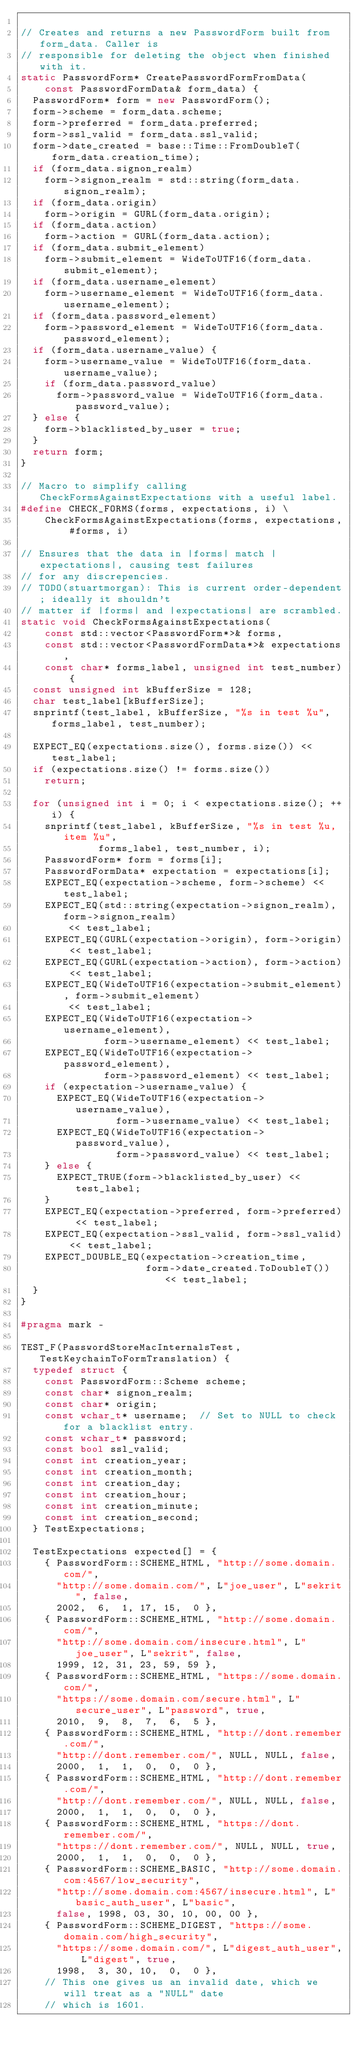Convert code to text. <code><loc_0><loc_0><loc_500><loc_500><_C++_>
// Creates and returns a new PasswordForm built from form_data. Caller is
// responsible for deleting the object when finished with it.
static PasswordForm* CreatePasswordFormFromData(
    const PasswordFormData& form_data) {
  PasswordForm* form = new PasswordForm();
  form->scheme = form_data.scheme;
  form->preferred = form_data.preferred;
  form->ssl_valid = form_data.ssl_valid;
  form->date_created = base::Time::FromDoubleT(form_data.creation_time);
  if (form_data.signon_realm)
    form->signon_realm = std::string(form_data.signon_realm);
  if (form_data.origin)
    form->origin = GURL(form_data.origin);
  if (form_data.action)
    form->action = GURL(form_data.action);
  if (form_data.submit_element)
    form->submit_element = WideToUTF16(form_data.submit_element);
  if (form_data.username_element)
    form->username_element = WideToUTF16(form_data.username_element);
  if (form_data.password_element)
    form->password_element = WideToUTF16(form_data.password_element);
  if (form_data.username_value) {
    form->username_value = WideToUTF16(form_data.username_value);
    if (form_data.password_value)
      form->password_value = WideToUTF16(form_data.password_value);
  } else {
    form->blacklisted_by_user = true;
  }
  return form;
}

// Macro to simplify calling CheckFormsAgainstExpectations with a useful label.
#define CHECK_FORMS(forms, expectations, i) \
    CheckFormsAgainstExpectations(forms, expectations, #forms, i)

// Ensures that the data in |forms| match |expectations|, causing test failures
// for any discrepencies.
// TODO(stuartmorgan): This is current order-dependent; ideally it shouldn't
// matter if |forms| and |expectations| are scrambled.
static void CheckFormsAgainstExpectations(
    const std::vector<PasswordForm*>& forms,
    const std::vector<PasswordFormData*>& expectations,
    const char* forms_label, unsigned int test_number) {
  const unsigned int kBufferSize = 128;
  char test_label[kBufferSize];
  snprintf(test_label, kBufferSize, "%s in test %u", forms_label, test_number);

  EXPECT_EQ(expectations.size(), forms.size()) << test_label;
  if (expectations.size() != forms.size())
    return;

  for (unsigned int i = 0; i < expectations.size(); ++i) {
    snprintf(test_label, kBufferSize, "%s in test %u, item %u",
             forms_label, test_number, i);
    PasswordForm* form = forms[i];
    PasswordFormData* expectation = expectations[i];
    EXPECT_EQ(expectation->scheme, form->scheme) << test_label;
    EXPECT_EQ(std::string(expectation->signon_realm), form->signon_realm)
        << test_label;
    EXPECT_EQ(GURL(expectation->origin), form->origin) << test_label;
    EXPECT_EQ(GURL(expectation->action), form->action) << test_label;
    EXPECT_EQ(WideToUTF16(expectation->submit_element), form->submit_element)
        << test_label;
    EXPECT_EQ(WideToUTF16(expectation->username_element),
              form->username_element) << test_label;
    EXPECT_EQ(WideToUTF16(expectation->password_element),
              form->password_element) << test_label;
    if (expectation->username_value) {
      EXPECT_EQ(WideToUTF16(expectation->username_value),
                form->username_value) << test_label;
      EXPECT_EQ(WideToUTF16(expectation->password_value),
                form->password_value) << test_label;
    } else {
      EXPECT_TRUE(form->blacklisted_by_user) << test_label;
    }
    EXPECT_EQ(expectation->preferred, form->preferred)  << test_label;
    EXPECT_EQ(expectation->ssl_valid, form->ssl_valid) << test_label;
    EXPECT_DOUBLE_EQ(expectation->creation_time,
                     form->date_created.ToDoubleT()) << test_label;
  }
}

#pragma mark -

TEST_F(PasswordStoreMacInternalsTest, TestKeychainToFormTranslation) {
  typedef struct {
    const PasswordForm::Scheme scheme;
    const char* signon_realm;
    const char* origin;
    const wchar_t* username;  // Set to NULL to check for a blacklist entry.
    const wchar_t* password;
    const bool ssl_valid;
    const int creation_year;
    const int creation_month;
    const int creation_day;
    const int creation_hour;
    const int creation_minute;
    const int creation_second;
  } TestExpectations;

  TestExpectations expected[] = {
    { PasswordForm::SCHEME_HTML, "http://some.domain.com/",
      "http://some.domain.com/", L"joe_user", L"sekrit", false,
      2002,  6,  1, 17, 15,  0 },
    { PasswordForm::SCHEME_HTML, "http://some.domain.com/",
      "http://some.domain.com/insecure.html", L"joe_user", L"sekrit", false,
      1999, 12, 31, 23, 59, 59 },
    { PasswordForm::SCHEME_HTML, "https://some.domain.com/",
      "https://some.domain.com/secure.html", L"secure_user", L"password", true,
      2010,  9,  8,  7,  6,  5 },
    { PasswordForm::SCHEME_HTML, "http://dont.remember.com/",
      "http://dont.remember.com/", NULL, NULL, false,
      2000,  1,  1,  0,  0,  0 },
    { PasswordForm::SCHEME_HTML, "http://dont.remember.com/",
      "http://dont.remember.com/", NULL, NULL, false,
      2000,  1,  1,  0,  0,  0 },
    { PasswordForm::SCHEME_HTML, "https://dont.remember.com/",
      "https://dont.remember.com/", NULL, NULL, true,
      2000,  1,  1,  0,  0,  0 },
    { PasswordForm::SCHEME_BASIC, "http://some.domain.com:4567/low_security",
      "http://some.domain.com:4567/insecure.html", L"basic_auth_user", L"basic",
      false, 1998, 03, 30, 10, 00, 00 },
    { PasswordForm::SCHEME_DIGEST, "https://some.domain.com/high_security",
      "https://some.domain.com/", L"digest_auth_user", L"digest", true,
      1998,  3, 30, 10,  0,  0 },
    // This one gives us an invalid date, which we will treat as a "NULL" date
    // which is 1601.</code> 